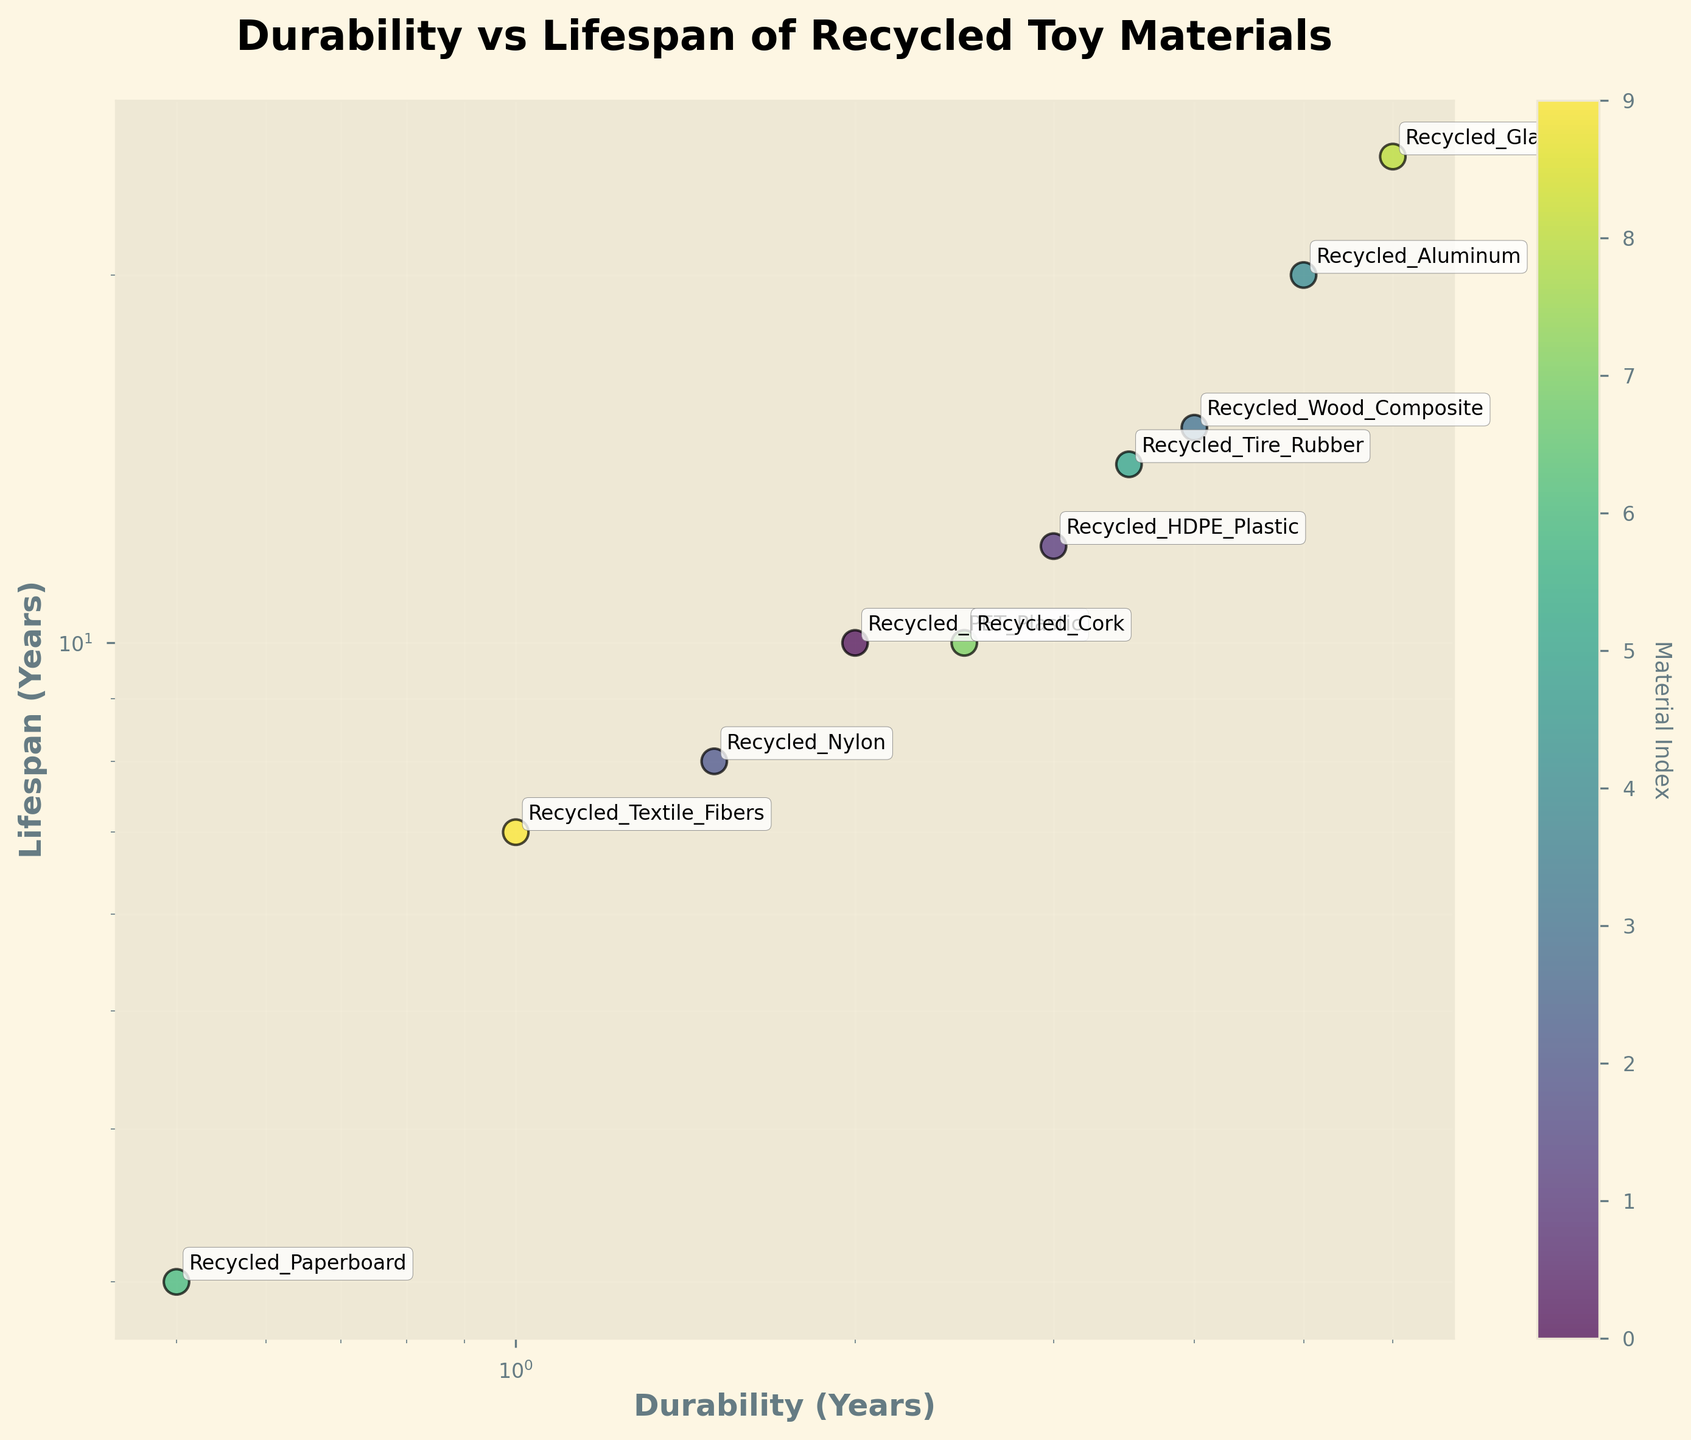How many materials have a durability less than 2 years? The scatter plot uses a log scale on the x-axis to represent durability in years. The points for Recycled_Nylon, Recycled_Textile_Fibers, and Recycled_Paperboard are positioned below the 2-year mark on the x-axis.
Answer: 3 Which material has the highest lifespan? The y-axis represents lifespan in years, and on the log scale, the point for Recycled_Glass is at the topmost position, indicating it has the highest lifespan compared to other materials.
Answer: Recycled_Glass What is the relationship between durability and lifespan for Recycled_Cork? Find the annotated point for Recycled_Cork on the scatter plot. The x-axis value for Recycled_Cork is approximately 2.5 years, and its y-axis value is 10 years.
Answer: Durability: 2.5 years, Lifespan: 10 years Are materials with higher durability generally associated with a higher lifespan? Observe the trend of the points in the scatter plot. Points with higher durability values on the x-axis (like Recycled_Aluminum and Recycled_Glass) are also positioned higher on the y-axis, indicating a higher lifespan. This suggests a positive correlation.
Answer: Yes Which material shows the lowest durability, and what is its lifespan? Locate the point for Recycled_Paperboard on the scatter plot, which has the lowest durability value on the x-axis. Its x-axis value is 0.5 years, and its y-axis value is 3 years.
Answer: Recycled_Paperboard: Durability: 0.5 years, Lifespan: 3 years What is the average lifespan of materials with a durability of 3 years or more? Identify materials with a durability of 3 years or more (Recycled_HDPE_Plastic, Recycled_Aluminum, Recycled_Tire_Rubber, Recycled_Wood_Composite, Recycled_Glass). Their lifespans are 12, 20, 14, 15, and 25 years, respectively. Average = (12 + 20 + 14 + 15 + 25) / 5 = 17.2 years.
Answer: 17.2 years Which material with a lifespan of less than 10 years has the highest durability? Identify materials with lifespans less than 10 years (Recycled_PET_Plastic, Recycled_Nylon, Recycled_Paperboard, Recycled_Textile_Fibers). Among these, Recycled_PET_Plastic has the highest durability of 2 years.
Answer: Recycled_PET_Plastic What is the ratio of durability to lifespan for Recycled_HDPE_Plastic? Find the annotated point for Recycled_HDPE_Plastic. Its durability is 3 years, and its lifespan is 12 years. Ratio = Durability / Lifespan = 3/12 = 0.25
Answer: 0.25 Are there any materials with a durability of less than 1 year and a lifespan exceeding 5 years? Based on the scatter plot, only Recycled_Paperboard has a durability of less than 1 year, and its lifespan is 3 years, which does not exceed 5 years.
Answer: No 